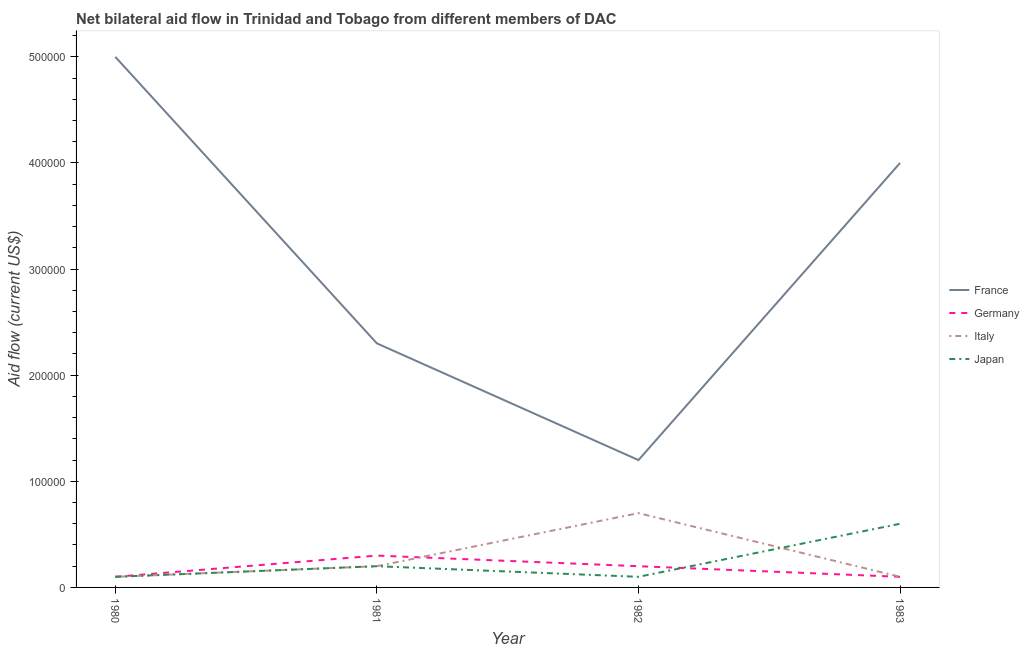How many different coloured lines are there?
Make the answer very short. 4. Does the line corresponding to amount of aid given by france intersect with the line corresponding to amount of aid given by italy?
Ensure brevity in your answer.  No. Is the number of lines equal to the number of legend labels?
Your response must be concise. Yes. What is the amount of aid given by japan in 1983?
Offer a very short reply. 6.00e+04. Across all years, what is the maximum amount of aid given by japan?
Provide a short and direct response. 6.00e+04. Across all years, what is the minimum amount of aid given by germany?
Your answer should be very brief. 10000. In which year was the amount of aid given by france maximum?
Your answer should be very brief. 1980. In which year was the amount of aid given by germany minimum?
Your answer should be very brief. 1980. What is the total amount of aid given by germany in the graph?
Your answer should be very brief. 7.00e+04. What is the difference between the amount of aid given by germany in 1980 and that in 1981?
Your answer should be very brief. -2.00e+04. What is the average amount of aid given by japan per year?
Your answer should be very brief. 2.50e+04. In the year 1981, what is the difference between the amount of aid given by japan and amount of aid given by france?
Ensure brevity in your answer.  -2.10e+05. In how many years, is the amount of aid given by italy greater than 340000 US$?
Offer a terse response. 0. What is the ratio of the amount of aid given by france in 1981 to that in 1982?
Offer a very short reply. 1.92. Is the difference between the amount of aid given by italy in 1980 and 1982 greater than the difference between the amount of aid given by japan in 1980 and 1982?
Offer a terse response. No. What is the difference between the highest and the second highest amount of aid given by italy?
Provide a short and direct response. 5.00e+04. What is the difference between the highest and the lowest amount of aid given by france?
Ensure brevity in your answer.  3.80e+05. In how many years, is the amount of aid given by france greater than the average amount of aid given by france taken over all years?
Make the answer very short. 2. Is it the case that in every year, the sum of the amount of aid given by japan and amount of aid given by germany is greater than the sum of amount of aid given by italy and amount of aid given by france?
Your answer should be compact. No. Is it the case that in every year, the sum of the amount of aid given by france and amount of aid given by germany is greater than the amount of aid given by italy?
Give a very brief answer. Yes. Does the amount of aid given by japan monotonically increase over the years?
Make the answer very short. No. Is the amount of aid given by japan strictly greater than the amount of aid given by france over the years?
Provide a succinct answer. No. Is the amount of aid given by france strictly less than the amount of aid given by japan over the years?
Offer a terse response. No. How many lines are there?
Offer a terse response. 4. Are the values on the major ticks of Y-axis written in scientific E-notation?
Your response must be concise. No. Where does the legend appear in the graph?
Your answer should be very brief. Center right. How many legend labels are there?
Your answer should be compact. 4. What is the title of the graph?
Your response must be concise. Net bilateral aid flow in Trinidad and Tobago from different members of DAC. What is the Aid flow (current US$) in France in 1980?
Offer a very short reply. 5.00e+05. What is the Aid flow (current US$) in Italy in 1980?
Provide a succinct answer. 10000. What is the Aid flow (current US$) in Japan in 1980?
Make the answer very short. 10000. What is the Aid flow (current US$) in France in 1981?
Your answer should be compact. 2.30e+05. What is the Aid flow (current US$) in Germany in 1981?
Provide a short and direct response. 3.00e+04. What is the Aid flow (current US$) of Germany in 1982?
Provide a succinct answer. 2.00e+04. What is the Aid flow (current US$) in France in 1983?
Offer a very short reply. 4.00e+05. What is the Aid flow (current US$) in Germany in 1983?
Make the answer very short. 10000. What is the Aid flow (current US$) in Italy in 1983?
Keep it short and to the point. 10000. What is the Aid flow (current US$) of Japan in 1983?
Offer a very short reply. 6.00e+04. Across all years, what is the maximum Aid flow (current US$) in Germany?
Your answer should be compact. 3.00e+04. Across all years, what is the minimum Aid flow (current US$) in France?
Ensure brevity in your answer.  1.20e+05. What is the total Aid flow (current US$) in France in the graph?
Provide a succinct answer. 1.25e+06. What is the total Aid flow (current US$) of Japan in the graph?
Offer a terse response. 1.00e+05. What is the difference between the Aid flow (current US$) in France in 1980 and that in 1981?
Ensure brevity in your answer.  2.70e+05. What is the difference between the Aid flow (current US$) of Germany in 1980 and that in 1981?
Offer a very short reply. -2.00e+04. What is the difference between the Aid flow (current US$) of France in 1980 and that in 1982?
Your answer should be compact. 3.80e+05. What is the difference between the Aid flow (current US$) in Japan in 1980 and that in 1982?
Offer a terse response. 0. What is the difference between the Aid flow (current US$) of France in 1980 and that in 1983?
Your response must be concise. 1.00e+05. What is the difference between the Aid flow (current US$) in Germany in 1981 and that in 1982?
Give a very brief answer. 10000. What is the difference between the Aid flow (current US$) of Japan in 1981 and that in 1982?
Give a very brief answer. 10000. What is the difference between the Aid flow (current US$) in Germany in 1981 and that in 1983?
Your response must be concise. 2.00e+04. What is the difference between the Aid flow (current US$) in France in 1982 and that in 1983?
Your answer should be compact. -2.80e+05. What is the difference between the Aid flow (current US$) in Italy in 1982 and that in 1983?
Keep it short and to the point. 6.00e+04. What is the difference between the Aid flow (current US$) of Japan in 1982 and that in 1983?
Give a very brief answer. -5.00e+04. What is the difference between the Aid flow (current US$) in Italy in 1980 and the Aid flow (current US$) in Japan in 1981?
Give a very brief answer. -10000. What is the difference between the Aid flow (current US$) in France in 1980 and the Aid flow (current US$) in Germany in 1982?
Provide a succinct answer. 4.80e+05. What is the difference between the Aid flow (current US$) of France in 1980 and the Aid flow (current US$) of Italy in 1982?
Offer a very short reply. 4.30e+05. What is the difference between the Aid flow (current US$) of France in 1980 and the Aid flow (current US$) of Japan in 1982?
Offer a terse response. 4.90e+05. What is the difference between the Aid flow (current US$) of Germany in 1980 and the Aid flow (current US$) of Japan in 1982?
Keep it short and to the point. 0. What is the difference between the Aid flow (current US$) of France in 1980 and the Aid flow (current US$) of Japan in 1983?
Your response must be concise. 4.40e+05. What is the difference between the Aid flow (current US$) in Germany in 1980 and the Aid flow (current US$) in Italy in 1983?
Keep it short and to the point. 0. What is the difference between the Aid flow (current US$) in Germany in 1980 and the Aid flow (current US$) in Japan in 1983?
Offer a terse response. -5.00e+04. What is the difference between the Aid flow (current US$) of Italy in 1980 and the Aid flow (current US$) of Japan in 1983?
Provide a short and direct response. -5.00e+04. What is the difference between the Aid flow (current US$) in France in 1981 and the Aid flow (current US$) in Germany in 1982?
Give a very brief answer. 2.10e+05. What is the difference between the Aid flow (current US$) in France in 1981 and the Aid flow (current US$) in Italy in 1982?
Your answer should be compact. 1.60e+05. What is the difference between the Aid flow (current US$) of Germany in 1981 and the Aid flow (current US$) of Italy in 1982?
Ensure brevity in your answer.  -4.00e+04. What is the difference between the Aid flow (current US$) of Germany in 1981 and the Aid flow (current US$) of Japan in 1982?
Provide a short and direct response. 2.00e+04. What is the difference between the Aid flow (current US$) of Italy in 1981 and the Aid flow (current US$) of Japan in 1982?
Ensure brevity in your answer.  10000. What is the difference between the Aid flow (current US$) of France in 1981 and the Aid flow (current US$) of Germany in 1983?
Keep it short and to the point. 2.20e+05. What is the difference between the Aid flow (current US$) in France in 1981 and the Aid flow (current US$) in Italy in 1983?
Offer a terse response. 2.20e+05. What is the difference between the Aid flow (current US$) of France in 1981 and the Aid flow (current US$) of Japan in 1983?
Give a very brief answer. 1.70e+05. What is the difference between the Aid flow (current US$) in Germany in 1981 and the Aid flow (current US$) in Italy in 1983?
Your answer should be compact. 2.00e+04. What is the difference between the Aid flow (current US$) in Germany in 1981 and the Aid flow (current US$) in Japan in 1983?
Offer a very short reply. -3.00e+04. What is the difference between the Aid flow (current US$) in Italy in 1981 and the Aid flow (current US$) in Japan in 1983?
Offer a terse response. -4.00e+04. What is the difference between the Aid flow (current US$) of France in 1982 and the Aid flow (current US$) of Germany in 1983?
Make the answer very short. 1.10e+05. What is the difference between the Aid flow (current US$) of France in 1982 and the Aid flow (current US$) of Japan in 1983?
Ensure brevity in your answer.  6.00e+04. What is the difference between the Aid flow (current US$) in Germany in 1982 and the Aid flow (current US$) in Italy in 1983?
Provide a short and direct response. 10000. What is the difference between the Aid flow (current US$) in Germany in 1982 and the Aid flow (current US$) in Japan in 1983?
Provide a short and direct response. -4.00e+04. What is the average Aid flow (current US$) in France per year?
Offer a very short reply. 3.12e+05. What is the average Aid flow (current US$) of Germany per year?
Ensure brevity in your answer.  1.75e+04. What is the average Aid flow (current US$) in Italy per year?
Give a very brief answer. 2.75e+04. What is the average Aid flow (current US$) in Japan per year?
Your response must be concise. 2.50e+04. In the year 1980, what is the difference between the Aid flow (current US$) of France and Aid flow (current US$) of Germany?
Provide a succinct answer. 4.90e+05. In the year 1980, what is the difference between the Aid flow (current US$) of Germany and Aid flow (current US$) of Italy?
Ensure brevity in your answer.  0. In the year 1981, what is the difference between the Aid flow (current US$) in France and Aid flow (current US$) in Italy?
Offer a terse response. 2.10e+05. In the year 1981, what is the difference between the Aid flow (current US$) in France and Aid flow (current US$) in Japan?
Give a very brief answer. 2.10e+05. In the year 1982, what is the difference between the Aid flow (current US$) of France and Aid flow (current US$) of Japan?
Your response must be concise. 1.10e+05. In the year 1983, what is the difference between the Aid flow (current US$) of France and Aid flow (current US$) of Germany?
Provide a succinct answer. 3.90e+05. In the year 1983, what is the difference between the Aid flow (current US$) of France and Aid flow (current US$) of Italy?
Ensure brevity in your answer.  3.90e+05. In the year 1983, what is the difference between the Aid flow (current US$) in France and Aid flow (current US$) in Japan?
Give a very brief answer. 3.40e+05. In the year 1983, what is the difference between the Aid flow (current US$) of Germany and Aid flow (current US$) of Italy?
Provide a short and direct response. 0. What is the ratio of the Aid flow (current US$) of France in 1980 to that in 1981?
Your answer should be compact. 2.17. What is the ratio of the Aid flow (current US$) in Japan in 1980 to that in 1981?
Your answer should be compact. 0.5. What is the ratio of the Aid flow (current US$) of France in 1980 to that in 1982?
Your response must be concise. 4.17. What is the ratio of the Aid flow (current US$) in Germany in 1980 to that in 1982?
Your answer should be compact. 0.5. What is the ratio of the Aid flow (current US$) of Italy in 1980 to that in 1982?
Your response must be concise. 0.14. What is the ratio of the Aid flow (current US$) of Japan in 1980 to that in 1982?
Provide a succinct answer. 1. What is the ratio of the Aid flow (current US$) in Germany in 1980 to that in 1983?
Provide a succinct answer. 1. What is the ratio of the Aid flow (current US$) in Japan in 1980 to that in 1983?
Your answer should be compact. 0.17. What is the ratio of the Aid flow (current US$) in France in 1981 to that in 1982?
Your response must be concise. 1.92. What is the ratio of the Aid flow (current US$) of Italy in 1981 to that in 1982?
Provide a succinct answer. 0.29. What is the ratio of the Aid flow (current US$) in France in 1981 to that in 1983?
Offer a terse response. 0.57. What is the ratio of the Aid flow (current US$) of Germany in 1981 to that in 1983?
Offer a terse response. 3. What is the ratio of the Aid flow (current US$) in Italy in 1982 to that in 1983?
Your answer should be very brief. 7. What is the ratio of the Aid flow (current US$) of Japan in 1982 to that in 1983?
Make the answer very short. 0.17. What is the difference between the highest and the second highest Aid flow (current US$) in France?
Ensure brevity in your answer.  1.00e+05. What is the difference between the highest and the second highest Aid flow (current US$) in Germany?
Provide a succinct answer. 10000. What is the difference between the highest and the second highest Aid flow (current US$) in Italy?
Provide a short and direct response. 5.00e+04. What is the difference between the highest and the second highest Aid flow (current US$) in Japan?
Make the answer very short. 4.00e+04. What is the difference between the highest and the lowest Aid flow (current US$) in Germany?
Make the answer very short. 2.00e+04. 